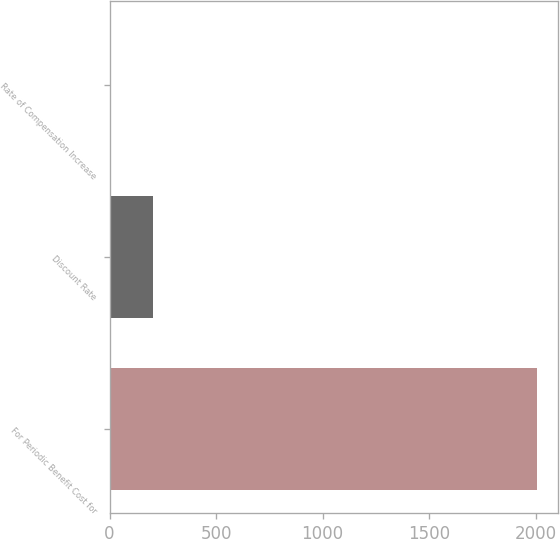Convert chart to OTSL. <chart><loc_0><loc_0><loc_500><loc_500><bar_chart><fcel>For Periodic Benefit Cost for<fcel>Discount Rate<fcel>Rate of Compensation Increase<nl><fcel>2004<fcel>204.45<fcel>4.5<nl></chart> 